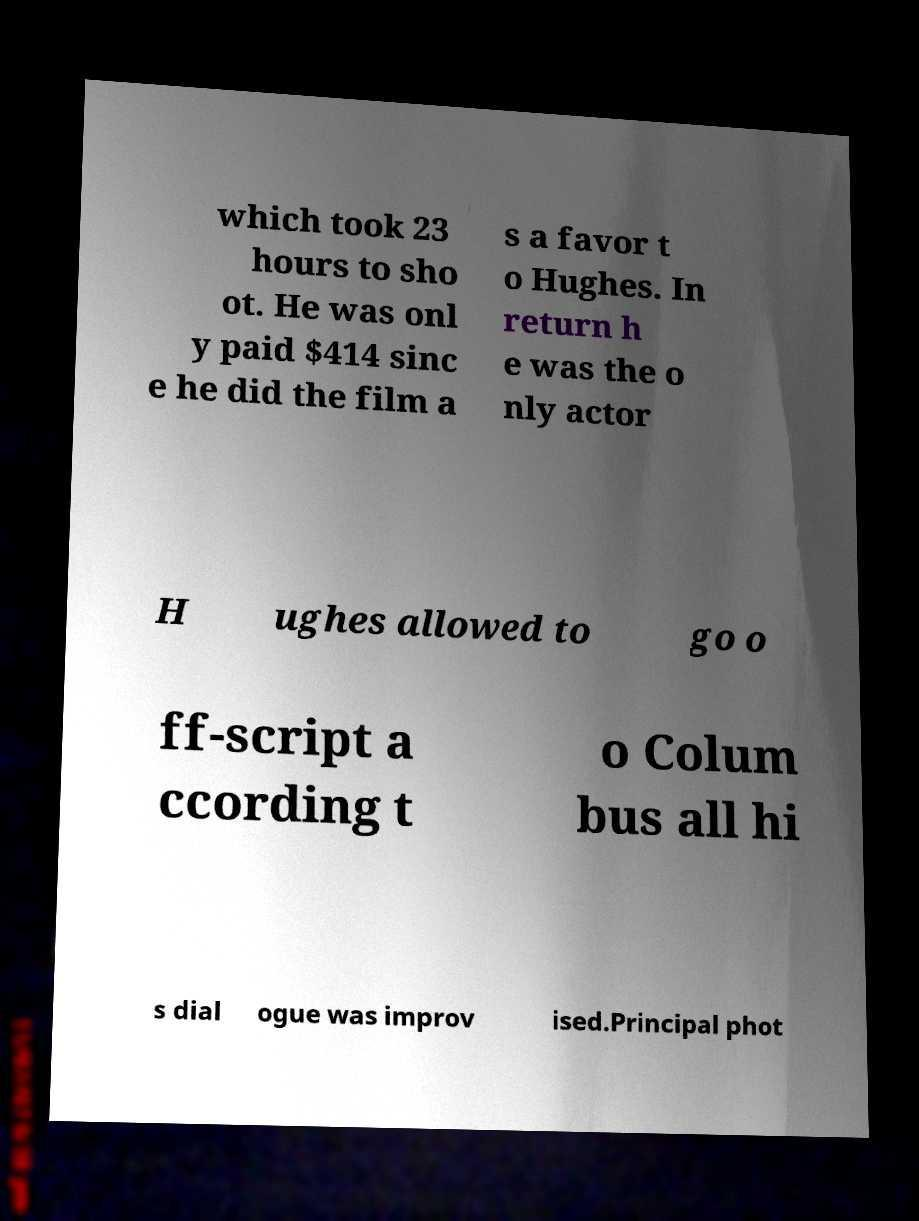Please identify and transcribe the text found in this image. which took 23 hours to sho ot. He was onl y paid $414 sinc e he did the film a s a favor t o Hughes. In return h e was the o nly actor H ughes allowed to go o ff-script a ccording t o Colum bus all hi s dial ogue was improv ised.Principal phot 